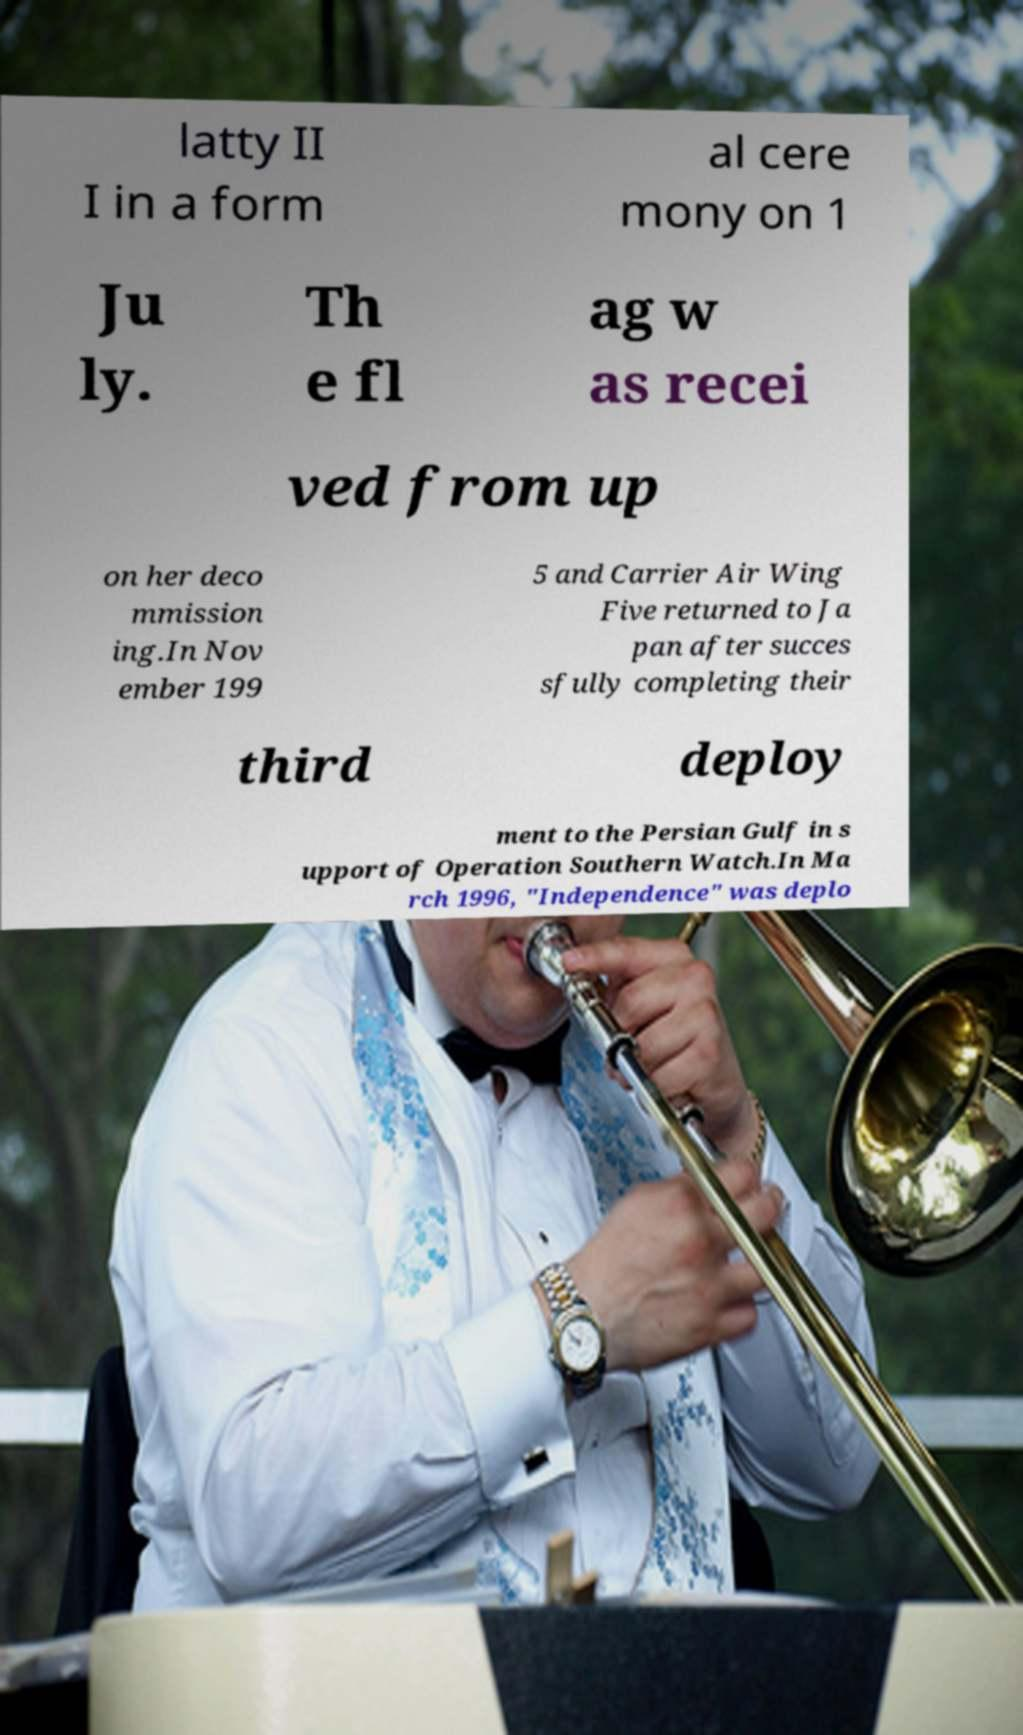Can you read and provide the text displayed in the image?This photo seems to have some interesting text. Can you extract and type it out for me? latty II I in a form al cere mony on 1 Ju ly. Th e fl ag w as recei ved from up on her deco mmission ing.In Nov ember 199 5 and Carrier Air Wing Five returned to Ja pan after succes sfully completing their third deploy ment to the Persian Gulf in s upport of Operation Southern Watch.In Ma rch 1996, "Independence" was deplo 